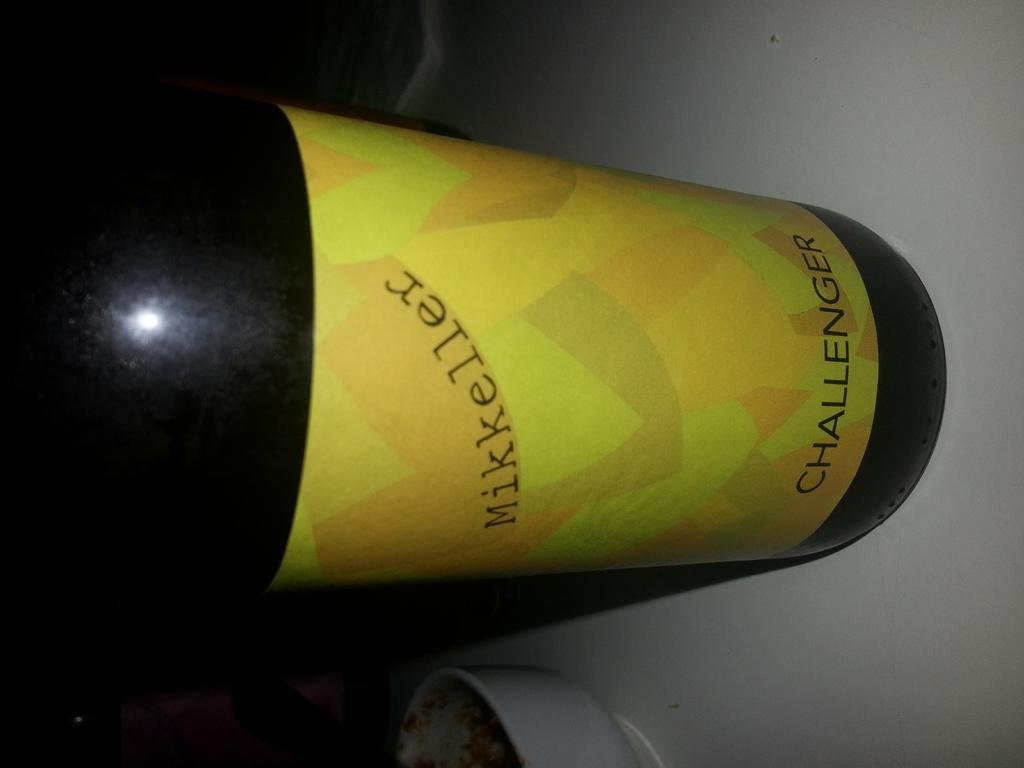Provide a one-sentence caption for the provided image. The type of drink is a Challenger from Mikkeller. 